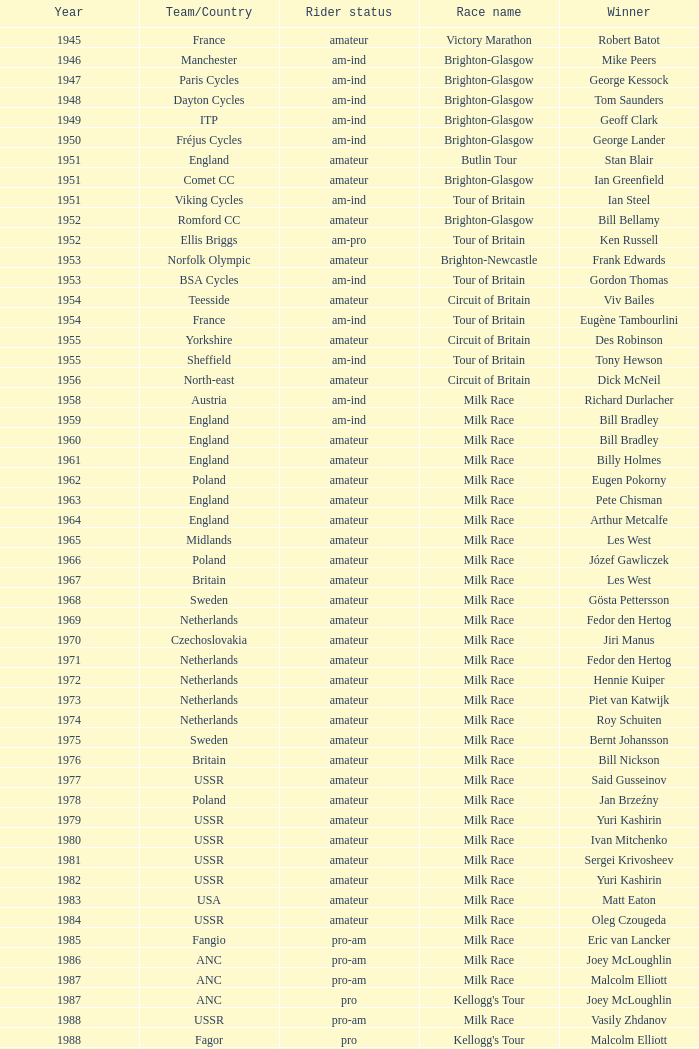Who was the winner in 1973 with an amateur rider status? Piet van Katwijk. Could you parse the entire table as a dict? {'header': ['Year', 'Team/Country', 'Rider status', 'Race name', 'Winner'], 'rows': [['1945', 'France', 'amateur', 'Victory Marathon', 'Robert Batot'], ['1946', 'Manchester', 'am-ind', 'Brighton-Glasgow', 'Mike Peers'], ['1947', 'Paris Cycles', 'am-ind', 'Brighton-Glasgow', 'George Kessock'], ['1948', 'Dayton Cycles', 'am-ind', 'Brighton-Glasgow', 'Tom Saunders'], ['1949', 'ITP', 'am-ind', 'Brighton-Glasgow', 'Geoff Clark'], ['1950', 'Fréjus Cycles', 'am-ind', 'Brighton-Glasgow', 'George Lander'], ['1951', 'England', 'amateur', 'Butlin Tour', 'Stan Blair'], ['1951', 'Comet CC', 'amateur', 'Brighton-Glasgow', 'Ian Greenfield'], ['1951', 'Viking Cycles', 'am-ind', 'Tour of Britain', 'Ian Steel'], ['1952', 'Romford CC', 'amateur', 'Brighton-Glasgow', 'Bill Bellamy'], ['1952', 'Ellis Briggs', 'am-pro', 'Tour of Britain', 'Ken Russell'], ['1953', 'Norfolk Olympic', 'amateur', 'Brighton-Newcastle', 'Frank Edwards'], ['1953', 'BSA Cycles', 'am-ind', 'Tour of Britain', 'Gordon Thomas'], ['1954', 'Teesside', 'amateur', 'Circuit of Britain', 'Viv Bailes'], ['1954', 'France', 'am-ind', 'Tour of Britain', 'Eugène Tambourlini'], ['1955', 'Yorkshire', 'amateur', 'Circuit of Britain', 'Des Robinson'], ['1955', 'Sheffield', 'am-ind', 'Tour of Britain', 'Tony Hewson'], ['1956', 'North-east', 'amateur', 'Circuit of Britain', 'Dick McNeil'], ['1958', 'Austria', 'am-ind', 'Milk Race', 'Richard Durlacher'], ['1959', 'England', 'am-ind', 'Milk Race', 'Bill Bradley'], ['1960', 'England', 'amateur', 'Milk Race', 'Bill Bradley'], ['1961', 'England', 'amateur', 'Milk Race', 'Billy Holmes'], ['1962', 'Poland', 'amateur', 'Milk Race', 'Eugen Pokorny'], ['1963', 'England', 'amateur', 'Milk Race', 'Pete Chisman'], ['1964', 'England', 'amateur', 'Milk Race', 'Arthur Metcalfe'], ['1965', 'Midlands', 'amateur', 'Milk Race', 'Les West'], ['1966', 'Poland', 'amateur', 'Milk Race', 'Józef Gawliczek'], ['1967', 'Britain', 'amateur', 'Milk Race', 'Les West'], ['1968', 'Sweden', 'amateur', 'Milk Race', 'Gösta Pettersson'], ['1969', 'Netherlands', 'amateur', 'Milk Race', 'Fedor den Hertog'], ['1970', 'Czechoslovakia', 'amateur', 'Milk Race', 'Jiri Manus'], ['1971', 'Netherlands', 'amateur', 'Milk Race', 'Fedor den Hertog'], ['1972', 'Netherlands', 'amateur', 'Milk Race', 'Hennie Kuiper'], ['1973', 'Netherlands', 'amateur', 'Milk Race', 'Piet van Katwijk'], ['1974', 'Netherlands', 'amateur', 'Milk Race', 'Roy Schuiten'], ['1975', 'Sweden', 'amateur', 'Milk Race', 'Bernt Johansson'], ['1976', 'Britain', 'amateur', 'Milk Race', 'Bill Nickson'], ['1977', 'USSR', 'amateur', 'Milk Race', 'Said Gusseinov'], ['1978', 'Poland', 'amateur', 'Milk Race', 'Jan Brzeźny'], ['1979', 'USSR', 'amateur', 'Milk Race', 'Yuri Kashirin'], ['1980', 'USSR', 'amateur', 'Milk Race', 'Ivan Mitchenko'], ['1981', 'USSR', 'amateur', 'Milk Race', 'Sergei Krivosheev'], ['1982', 'USSR', 'amateur', 'Milk Race', 'Yuri Kashirin'], ['1983', 'USA', 'amateur', 'Milk Race', 'Matt Eaton'], ['1984', 'USSR', 'amateur', 'Milk Race', 'Oleg Czougeda'], ['1985', 'Fangio', 'pro-am', 'Milk Race', 'Eric van Lancker'], ['1986', 'ANC', 'pro-am', 'Milk Race', 'Joey McLoughlin'], ['1987', 'ANC', 'pro-am', 'Milk Race', 'Malcolm Elliott'], ['1987', 'ANC', 'pro', "Kellogg's Tour", 'Joey McLoughlin'], ['1988', 'USSR', 'pro-am', 'Milk Race', 'Vasily Zhdanov'], ['1988', 'Fagor', 'pro', "Kellogg's Tour", 'Malcolm Elliott'], ['1989', '7-Eleven', 'pro-am', 'Milk Race', 'Brian Walton'], ['1989', 'Z-Peugeot', 'pro', "Kellogg's Tour", 'Robert Millar'], ['1990', 'Banana', 'pro-am', 'Milk Race', 'Shane Sutton'], ['1990', 'Weinnmann-SMM', 'pro', "Kellogg's Tour", 'Michel Dernies'], ['1991', 'Banana', 'pro-am', 'Milk Race', 'Chris Walker'], ['1991', 'Motorola', 'pro', "Kellogg's Tour", 'Phil Anderson'], ['1992', 'Ireland', 'pro-am', 'Milk Race', 'Conor Henry'], ['1992', 'Motorola', 'pro', "Kellogg's Tour", 'Max Sciandri'], ['1993', 'Banana', 'pro-am', 'Milk Race', 'Chris Lillywhite'], ['1993', 'Motorola', 'pro', "Kellogg's Tour", 'Phil Anderson'], ['1994', 'Lampre', 'pro', "Kellogg's Tour", 'Maurizio Fondriest'], ['1998', 'Crédit Agricole', 'pro', 'PruTour', "Stuart O'Grady"], ['1999', 'Rabobank', 'pro', 'PruTour', 'Marc Wauters']]} 